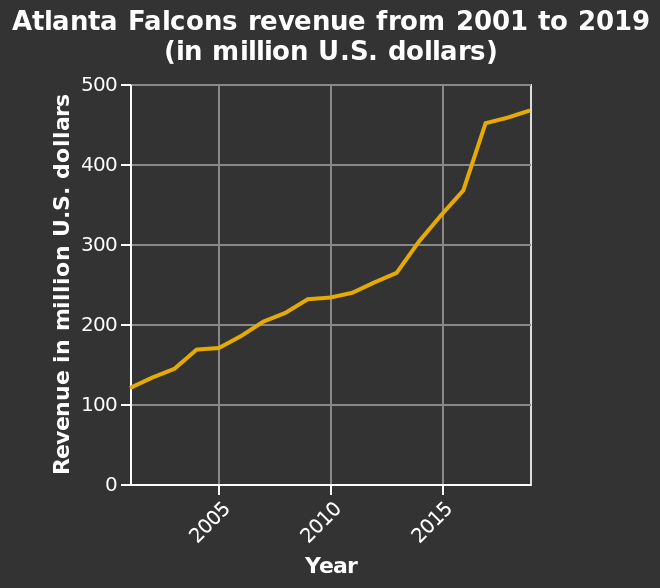<image>
What is the range of the y-axis in the line plot?  The range of the y-axis in the line plot is from 0 to 500 million U.S. dollars. What was the revenue in 2000?  The revenue in 2000 was about 125 million. In which unit is the revenue represented on the y-axis?  The revenue is represented in million U.S. dollars on the y-axis. 